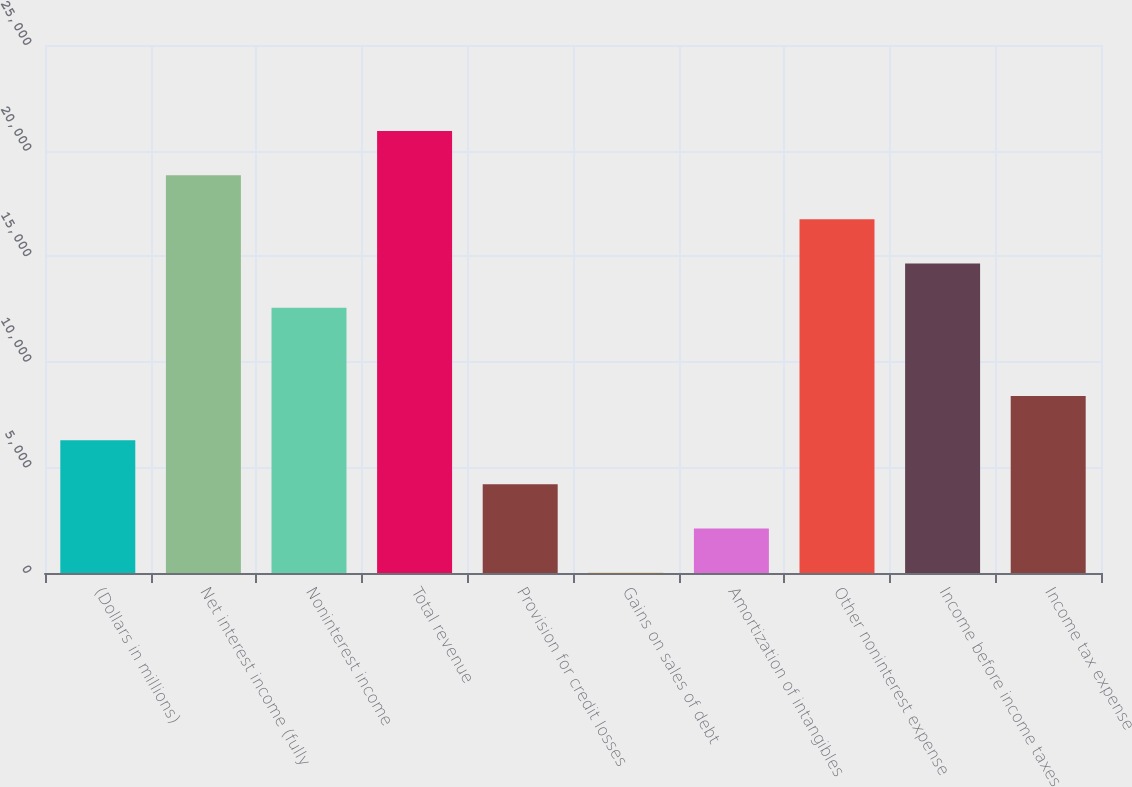Convert chart to OTSL. <chart><loc_0><loc_0><loc_500><loc_500><bar_chart><fcel>(Dollars in millions)<fcel>Net interest income (fully<fcel>Noninterest income<fcel>Total revenue<fcel>Provision for credit losses<fcel>Gains on sales of debt<fcel>Amortization of intangibles<fcel>Other noninterest expense<fcel>Income before income taxes<fcel>Income tax expense<nl><fcel>6288.1<fcel>18838.3<fcel>12563.2<fcel>20930<fcel>4196.4<fcel>13<fcel>2104.7<fcel>16746.6<fcel>14654.9<fcel>8379.8<nl></chart> 